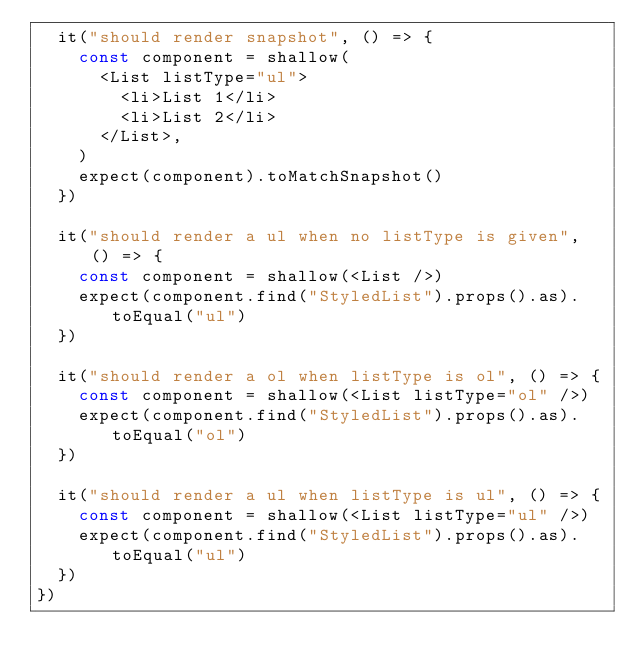<code> <loc_0><loc_0><loc_500><loc_500><_JavaScript_>  it("should render snapshot", () => {
    const component = shallow(
      <List listType="ul">
        <li>List 1</li>
        <li>List 2</li>
      </List>,
    )
    expect(component).toMatchSnapshot()
  })

  it("should render a ul when no listType is given", () => {
    const component = shallow(<List />)
    expect(component.find("StyledList").props().as).toEqual("ul")
  })

  it("should render a ol when listType is ol", () => {
    const component = shallow(<List listType="ol" />)
    expect(component.find("StyledList").props().as).toEqual("ol")
  })

  it("should render a ul when listType is ul", () => {
    const component = shallow(<List listType="ul" />)
    expect(component.find("StyledList").props().as).toEqual("ul")
  })
})
</code> 